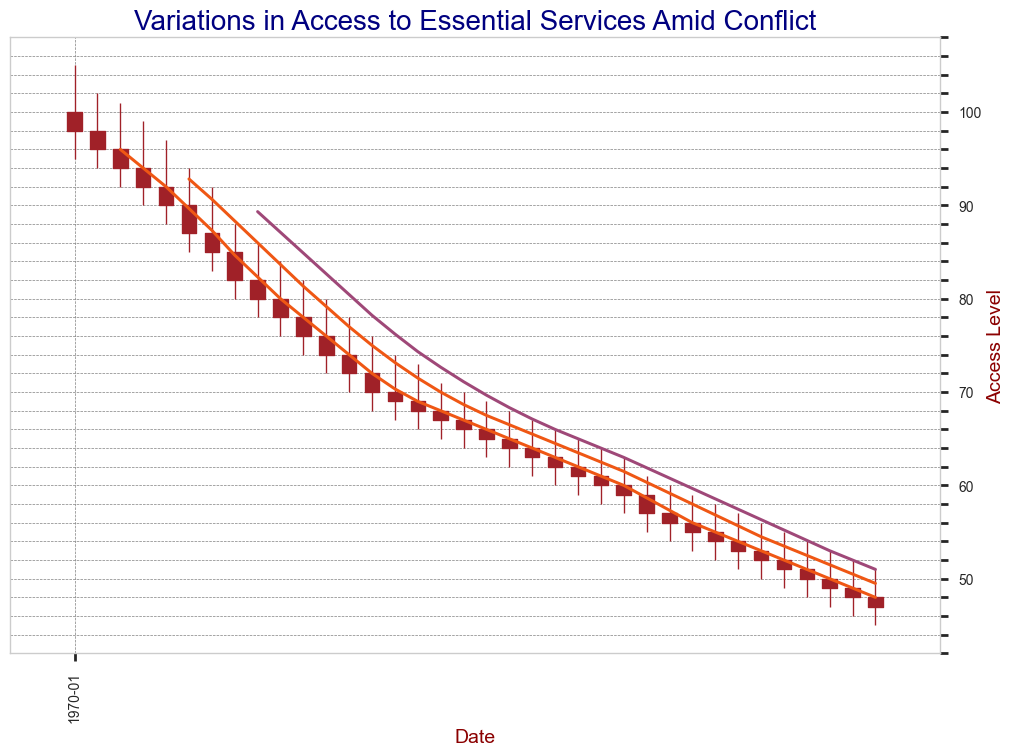What is the closing value in January 2024? To find the closing value for January 2024, locate the date on the x-axis and look for the closing value of the candlestick. In this case, it corresponds to the horizontal line at the end of the body of the candle for January 2024.
Answer: 72 How does the closing value in December 2024 compare to that in December 2023? Find the closing values for December 2024 and December 2023 by locating the respective dates and seeing where the body of the candlestick ends. Then, compare these values. The closing value for December 2024 is 60, while for December 2023 it is 74. December 2024's closing value is lower.
Answer: Lower What is the highest value recorded during April 2024? To find the highest value recorded in April 2024, locate the candlestick for that month and check the upper wick's highest point.
Answer: 73 What's the general trend observed from January 2023 to December 2025? Observe the overall movement of the candlestick bodies and wicks from January 2023 to December 2025. The bars are generally moving downward, indicating a decreasing trend.
Answer: Decreasing trend By how much did the closing value decrease from February 2025 to March 2025? Identify the closing values for February 2025 and March 2025. Subtract the March 2025 closing value (56) from February 2025 closing value (57) to find the decrease amount.
Answer: 1 Compare the closing values for June 2023 and June 2024. Locate the closing values for June 2023 (87) and June 2024 (66). Compare these two values to determine which is higher.
Answer: June 2023 is higher How many times did the closing value change direction from increasing to decreasing or vice versa in 2024? Examine the closing values month by month in 2024 and count the number of transitions from increasing to decreasing or vice versa. There are changes in February, July, and October, making a total of 3 changes.
Answer: 3 What is the percentage decrease in the closing value from January 2023 to December 2025? The closing value in January 2023 is 98, and in December 2025 is 47. The percentage decrease can be calculated as ((98-47)/98)*100. 
((98 - 47)/98) * 100 approximately equals 52%.
Answer: 52% Which month in 2024 had the lowest closing value and what was it? Check all the closing values for each month in 2024. The month with the lowest closing value is December 2024 with a closing value of 60.
Answer: December, 60 